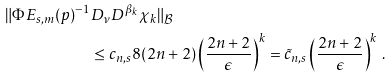<formula> <loc_0><loc_0><loc_500><loc_500>\| \Phi E _ { s , m } ( p ) ^ { - 1 } & D _ { \nu } D ^ { \beta _ { k } } \chi _ { k } \| _ { \mathcal { B } } \\ & \leq c _ { n , s } 8 ( 2 n + 2 ) \left ( \frac { 2 n + 2 } { \epsilon } \right ) ^ { k } = \tilde { c } _ { n , s } \left ( \frac { 2 n + 2 } { \epsilon } \right ) ^ { k } \, .</formula> 